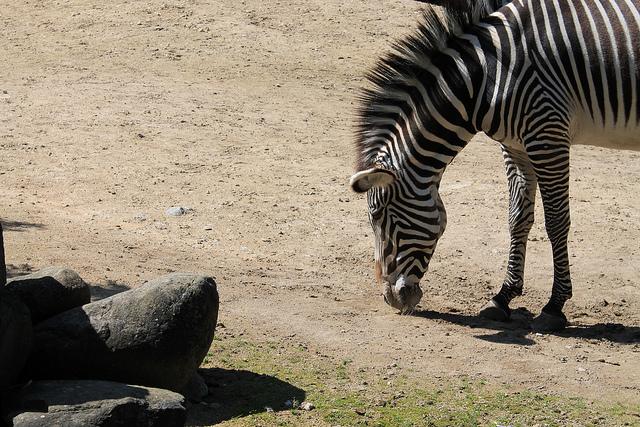Does this animal have four legs?
Concise answer only. Yes. What is the zebra doing?
Answer briefly. Grazing. What is the zebra eating?
Short answer required. Dirt. What part of the animal is facing the photo?
Give a very brief answer. Head. How many different animals are in this picture?
Short answer required. 1. What direction is the zebra looking?
Short answer required. Down. How many zebras?
Quick response, please. 1. How old is this zebra?
Write a very short answer. 5. What is the animal eating?
Short answer required. Dirt. 